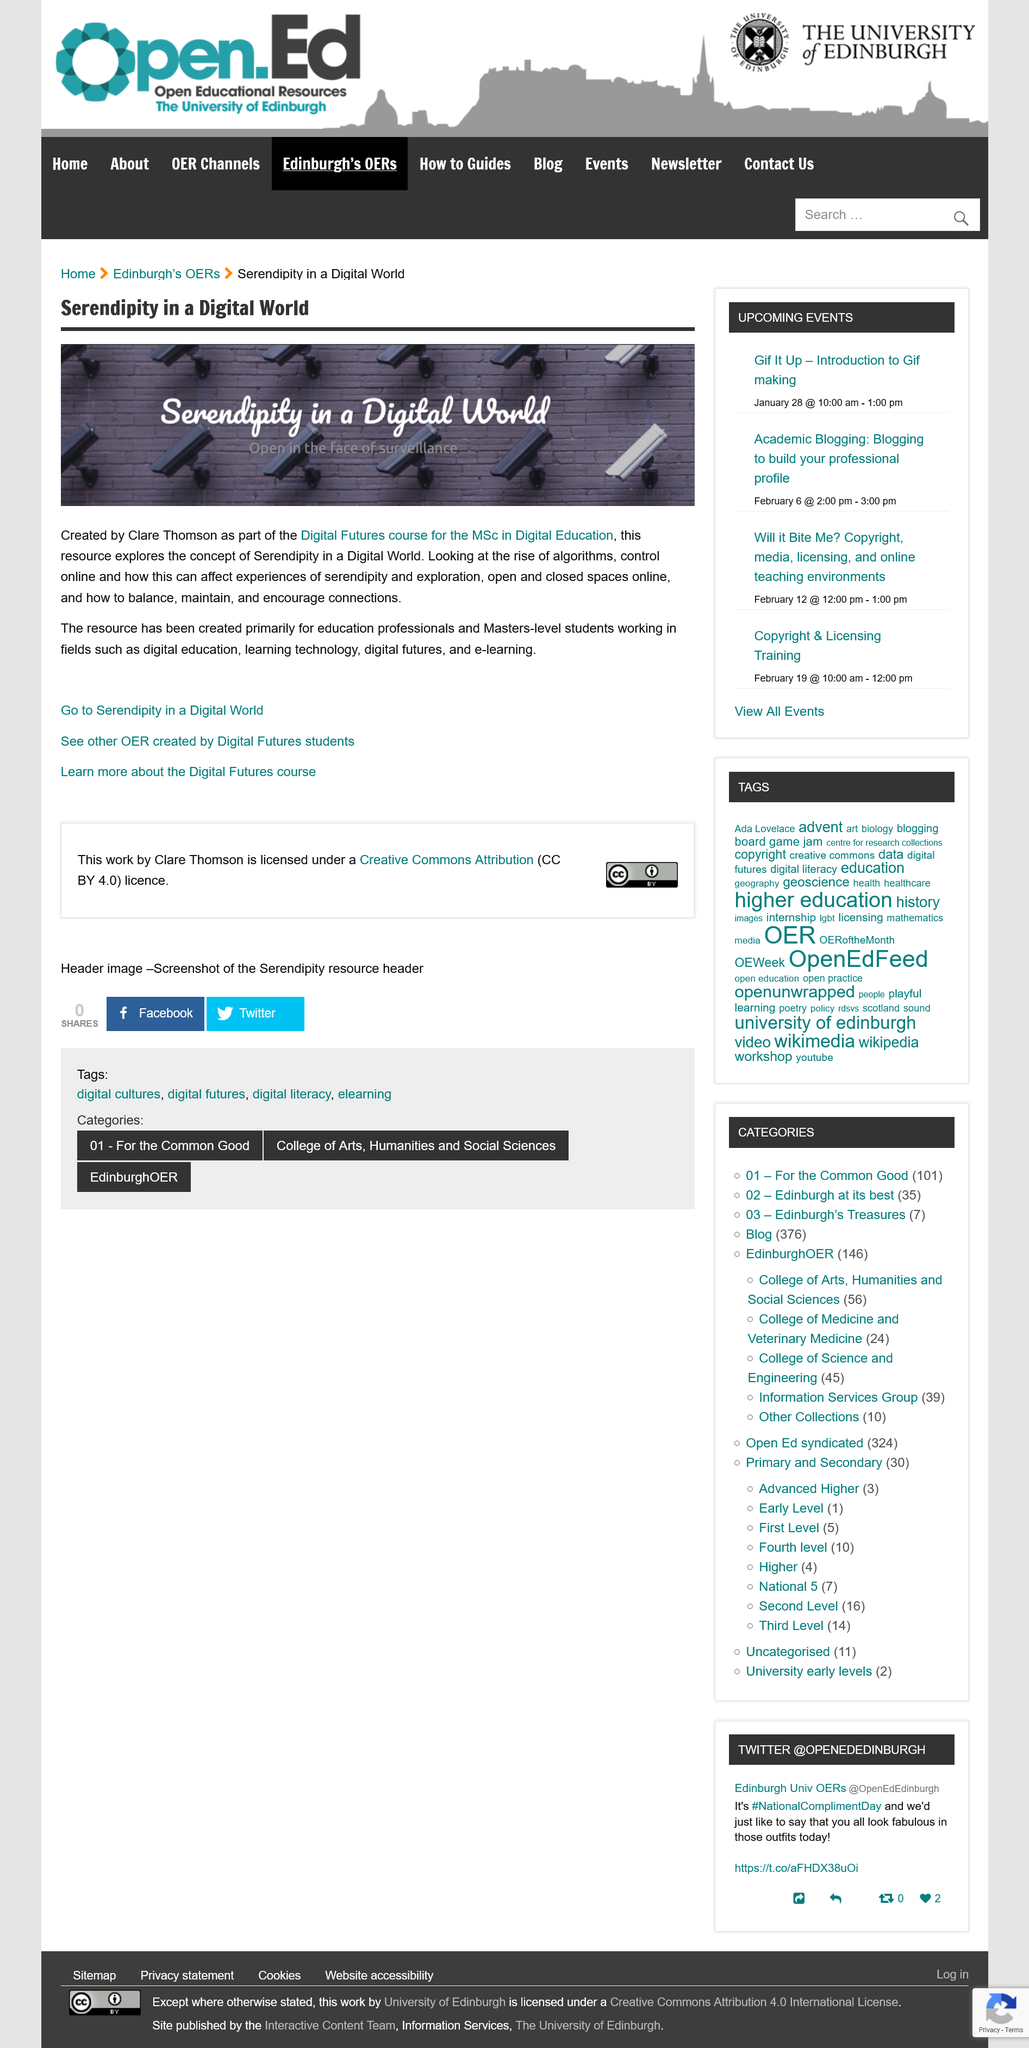Draw attention to some important aspects in this diagram. The third link in the article enables you to acquire additional information about the Digital Futures course. Clare Thomson is the creator of Serendipity in a Digital World. Yes, this resource was created specifically for the use of Masters-level students. 